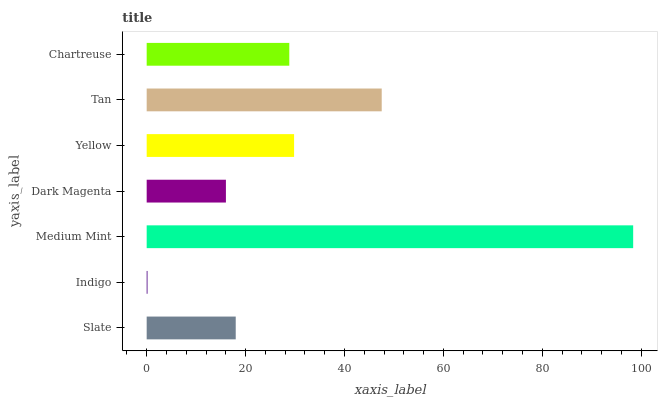Is Indigo the minimum?
Answer yes or no. Yes. Is Medium Mint the maximum?
Answer yes or no. Yes. Is Medium Mint the minimum?
Answer yes or no. No. Is Indigo the maximum?
Answer yes or no. No. Is Medium Mint greater than Indigo?
Answer yes or no. Yes. Is Indigo less than Medium Mint?
Answer yes or no. Yes. Is Indigo greater than Medium Mint?
Answer yes or no. No. Is Medium Mint less than Indigo?
Answer yes or no. No. Is Chartreuse the high median?
Answer yes or no. Yes. Is Chartreuse the low median?
Answer yes or no. Yes. Is Medium Mint the high median?
Answer yes or no. No. Is Dark Magenta the low median?
Answer yes or no. No. 